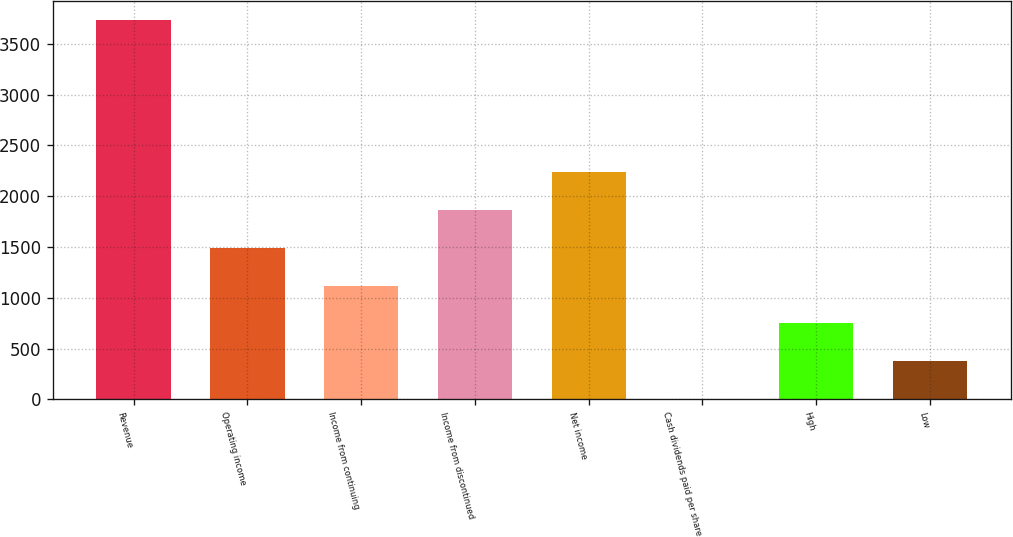<chart> <loc_0><loc_0><loc_500><loc_500><bar_chart><fcel>Revenue<fcel>Operating income<fcel>Income from continuing<fcel>Income from discontinued<fcel>Net income<fcel>Cash dividends paid per share<fcel>High<fcel>Low<nl><fcel>3735<fcel>1494.05<fcel>1120.56<fcel>1867.54<fcel>2241.03<fcel>0.09<fcel>747.07<fcel>373.58<nl></chart> 